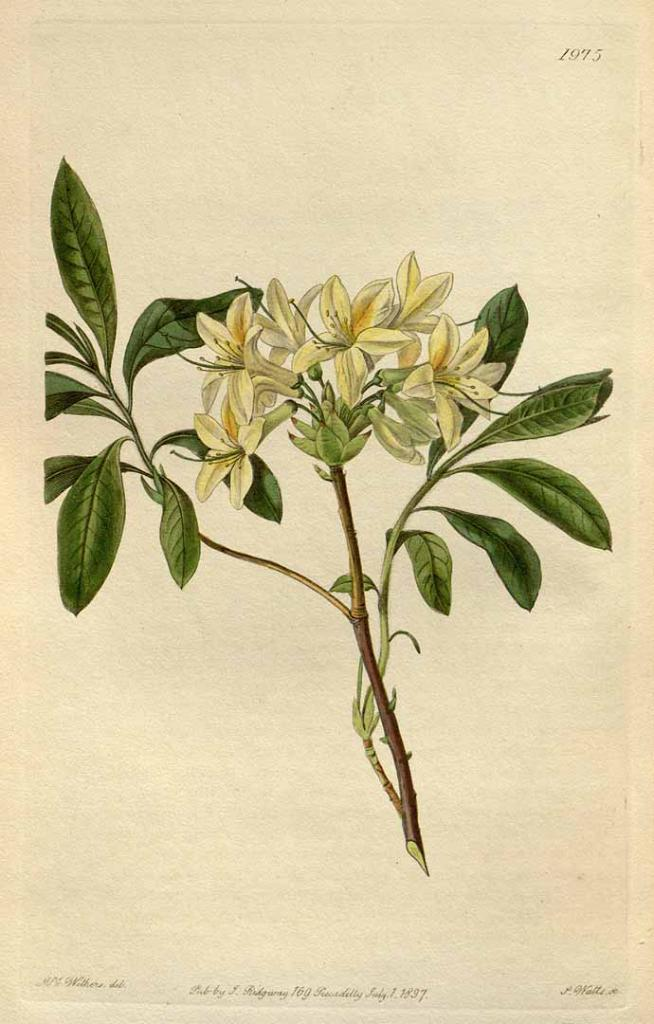What type of plant parts can be seen in the image? There are green leaves, stems, and flowers in the image. What is written in the image? There is text written at the top and bottom portions of the image. What color is the dress worn by the moon in the image? There is no moon or dress present in the image. What type of chalk is used to write the text in the image? The facts provided do not mention any chalk being used to write the text in the image. 